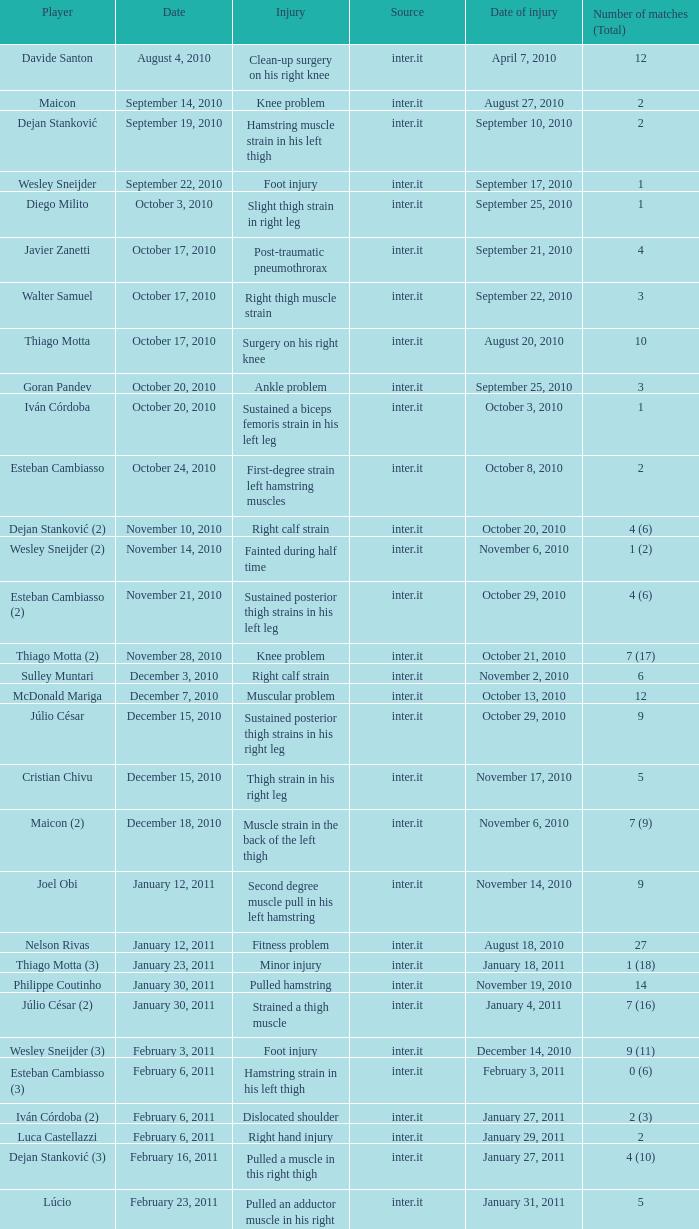What is the date of injury when the injury is foot injury and the number of matches (total) is 1? September 17, 2010. 